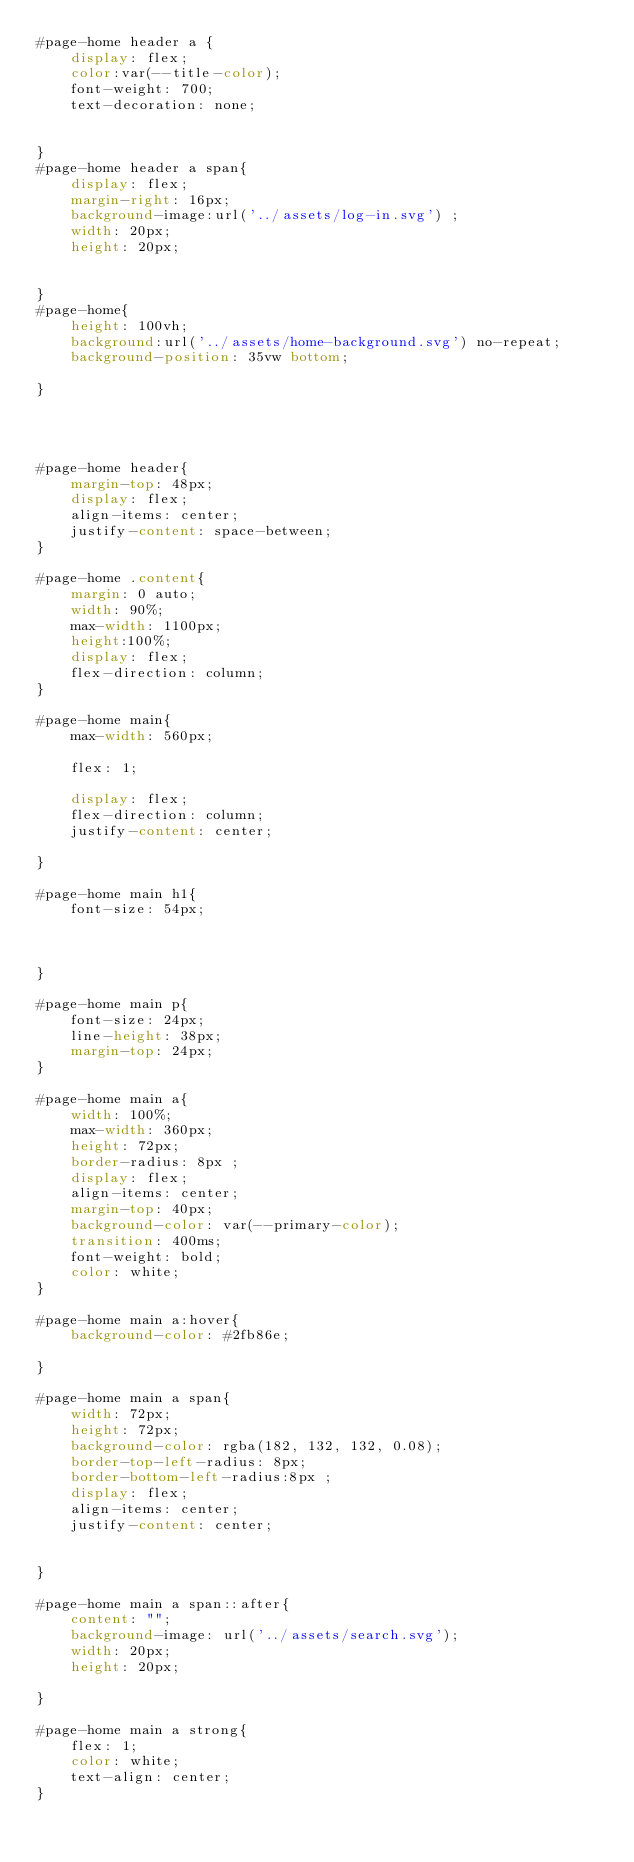Convert code to text. <code><loc_0><loc_0><loc_500><loc_500><_CSS_>#page-home header a {
    display: flex;
    color:var(--title-color);
    font-weight: 700;
    text-decoration: none;
    

}
#page-home header a span{
    display: flex;
    margin-right: 16px;
    background-image:url('../assets/log-in.svg') ;
    width: 20px;
    height: 20px;


}
#page-home{
    height: 100vh;
    background:url('../assets/home-background.svg') no-repeat;
    background-position: 35vw bottom;

}




#page-home header{
    margin-top: 48px;
    display: flex;
    align-items: center;
    justify-content: space-between;
}

#page-home .content{
    margin: 0 auto;
    width: 90%;
    max-width: 1100px;
    height:100%;
    display: flex;
    flex-direction: column;
}

#page-home main{
    max-width: 560px;

    flex: 1;

    display: flex;
    flex-direction: column;
    justify-content: center;

}

#page-home main h1{
    font-size: 54px;
   

    
}

#page-home main p{
    font-size: 24px;
    line-height: 38px;
    margin-top: 24px;
}

#page-home main a{
    width: 100%;
    max-width: 360px;
    height: 72px;
    border-radius: 8px ;
    display: flex;
    align-items: center;
    margin-top: 40px;
    background-color: var(--primary-color);
    transition: 400ms;
    font-weight: bold;
    color: white;
}

#page-home main a:hover{
    background-color: #2fb86e;

}

#page-home main a span{
    width: 72px;
    height: 72px;
    background-color: rgba(182, 132, 132, 0.08);
    border-top-left-radius: 8px;
    border-bottom-left-radius:8px ;
    display: flex;
    align-items: center;
    justify-content: center;


}

#page-home main a span::after{
    content: "";
    background-image: url('../assets/search.svg');
    width: 20px;
    height: 20px;

}

#page-home main a strong{
    flex: 1;
    color: white;
    text-align: center;
}
</code> 